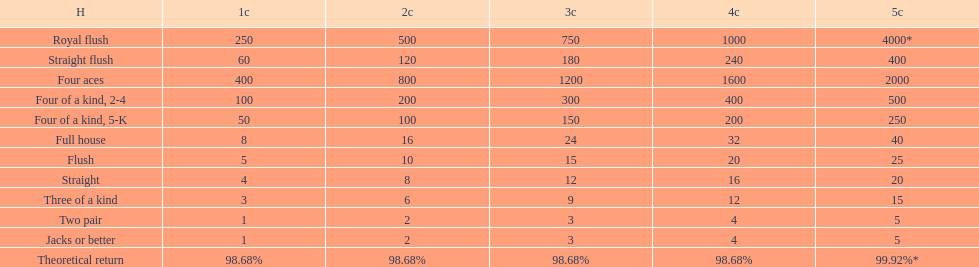After winning on four credits with a full house, what is your payout? 32. 